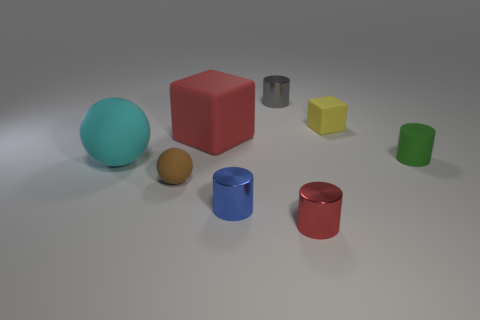Subtract all green spheres. Subtract all brown cubes. How many spheres are left? 2 Add 1 tiny blue cylinders. How many objects exist? 9 Subtract all cubes. How many objects are left? 6 Add 8 tiny balls. How many tiny balls exist? 9 Subtract 0 blue balls. How many objects are left? 8 Subtract all tiny matte objects. Subtract all matte objects. How many objects are left? 0 Add 3 small blue things. How many small blue things are left? 4 